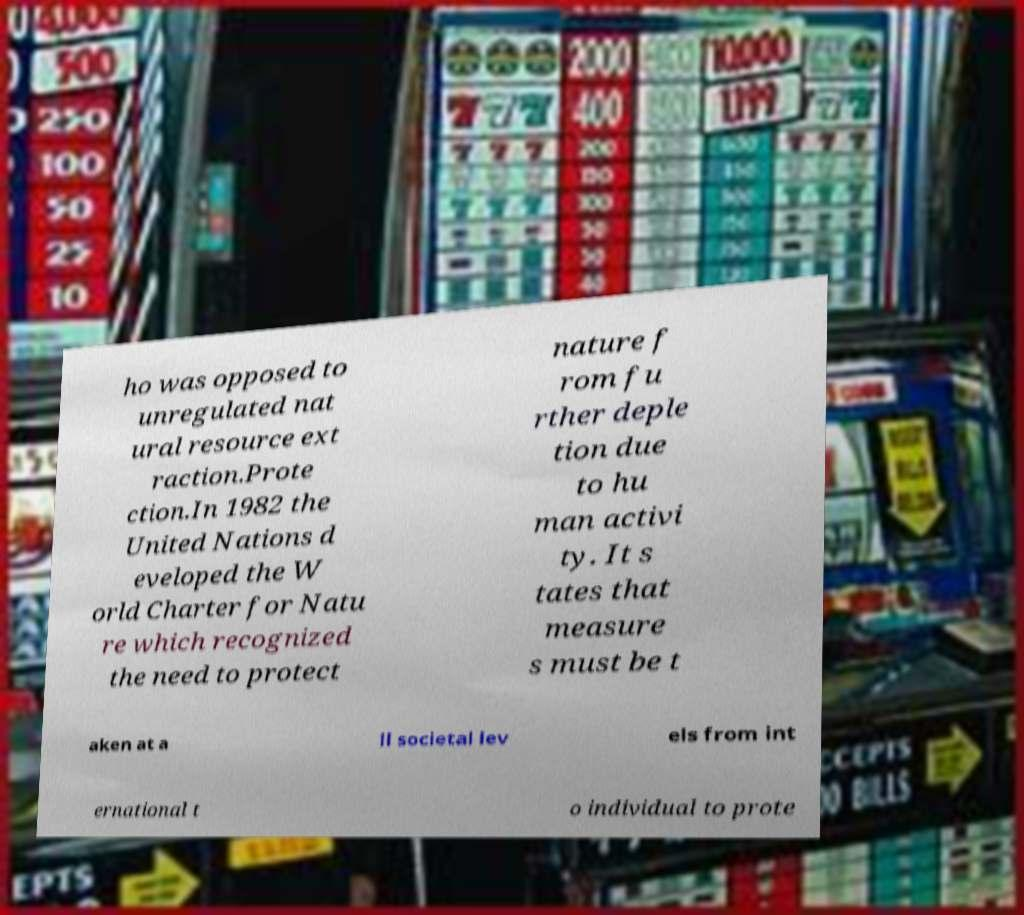Could you assist in decoding the text presented in this image and type it out clearly? ho was opposed to unregulated nat ural resource ext raction.Prote ction.In 1982 the United Nations d eveloped the W orld Charter for Natu re which recognized the need to protect nature f rom fu rther deple tion due to hu man activi ty. It s tates that measure s must be t aken at a ll societal lev els from int ernational t o individual to prote 